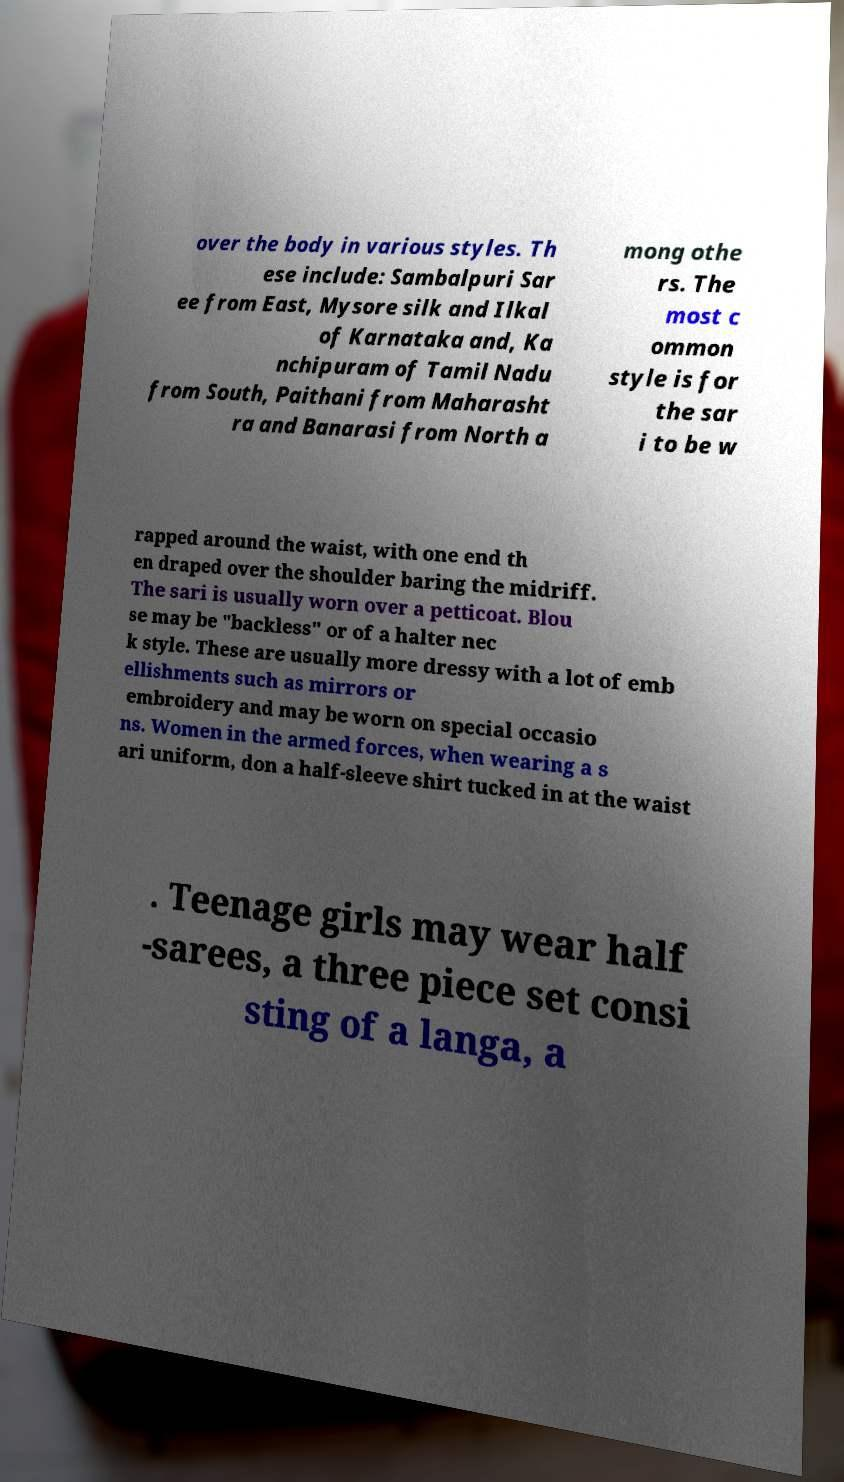Please identify and transcribe the text found in this image. over the body in various styles. Th ese include: Sambalpuri Sar ee from East, Mysore silk and Ilkal of Karnataka and, Ka nchipuram of Tamil Nadu from South, Paithani from Maharasht ra and Banarasi from North a mong othe rs. The most c ommon style is for the sar i to be w rapped around the waist, with one end th en draped over the shoulder baring the midriff. The sari is usually worn over a petticoat. Blou se may be "backless" or of a halter nec k style. These are usually more dressy with a lot of emb ellishments such as mirrors or embroidery and may be worn on special occasio ns. Women in the armed forces, when wearing a s ari uniform, don a half-sleeve shirt tucked in at the waist . Teenage girls may wear half -sarees, a three piece set consi sting of a langa, a 